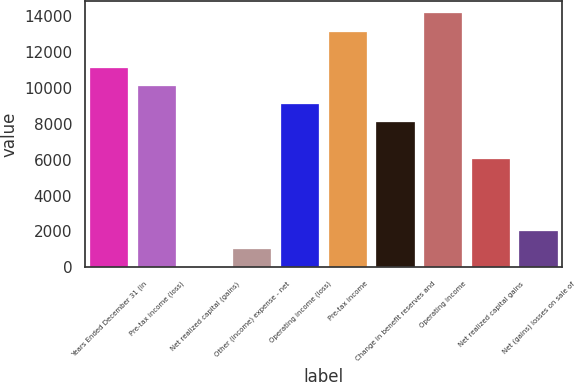Convert chart. <chart><loc_0><loc_0><loc_500><loc_500><bar_chart><fcel>Years Ended December 31 (in<fcel>Pre-tax income (loss)<fcel>Net realized capital (gains)<fcel>Other (income) expense - net<fcel>Operating income (loss)<fcel>Pre-tax income<fcel>Change in benefit reserves and<fcel>Operating income<fcel>Net realized capital gains<fcel>Net (gains) losses on sale of<nl><fcel>11114.2<fcel>10104<fcel>2<fcel>1012.2<fcel>9093.8<fcel>13134.6<fcel>8083.6<fcel>14144.8<fcel>6063.2<fcel>2022.4<nl></chart> 